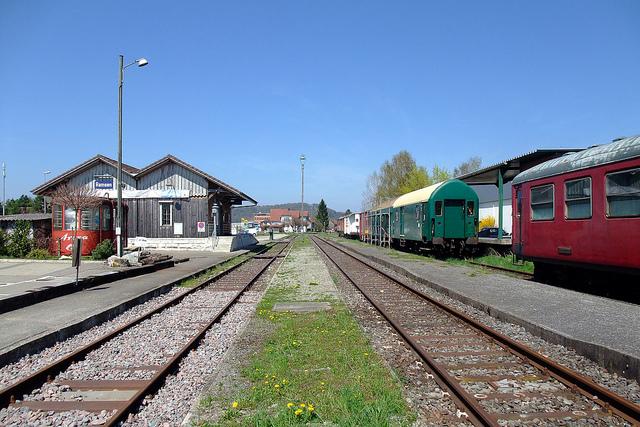Is the train in motion?
Answer briefly. No. What color is the building on the right?
Short answer required. White. Are there any people in this scene?
Keep it brief. No. How many tracks are seen?
Give a very brief answer. 2. Are this tracks rails?
Give a very brief answer. Yes. 